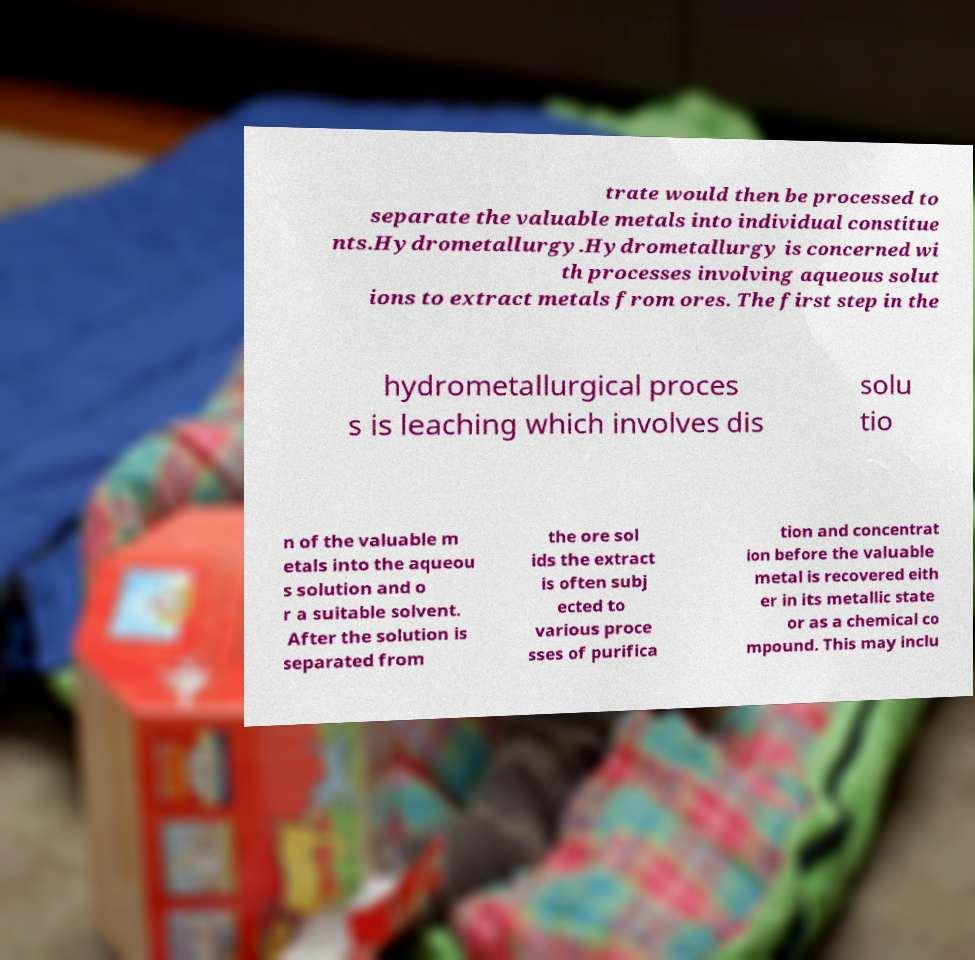Could you extract and type out the text from this image? trate would then be processed to separate the valuable metals into individual constitue nts.Hydrometallurgy.Hydrometallurgy is concerned wi th processes involving aqueous solut ions to extract metals from ores. The first step in the hydrometallurgical proces s is leaching which involves dis solu tio n of the valuable m etals into the aqueou s solution and o r a suitable solvent. After the solution is separated from the ore sol ids the extract is often subj ected to various proce sses of purifica tion and concentrat ion before the valuable metal is recovered eith er in its metallic state or as a chemical co mpound. This may inclu 